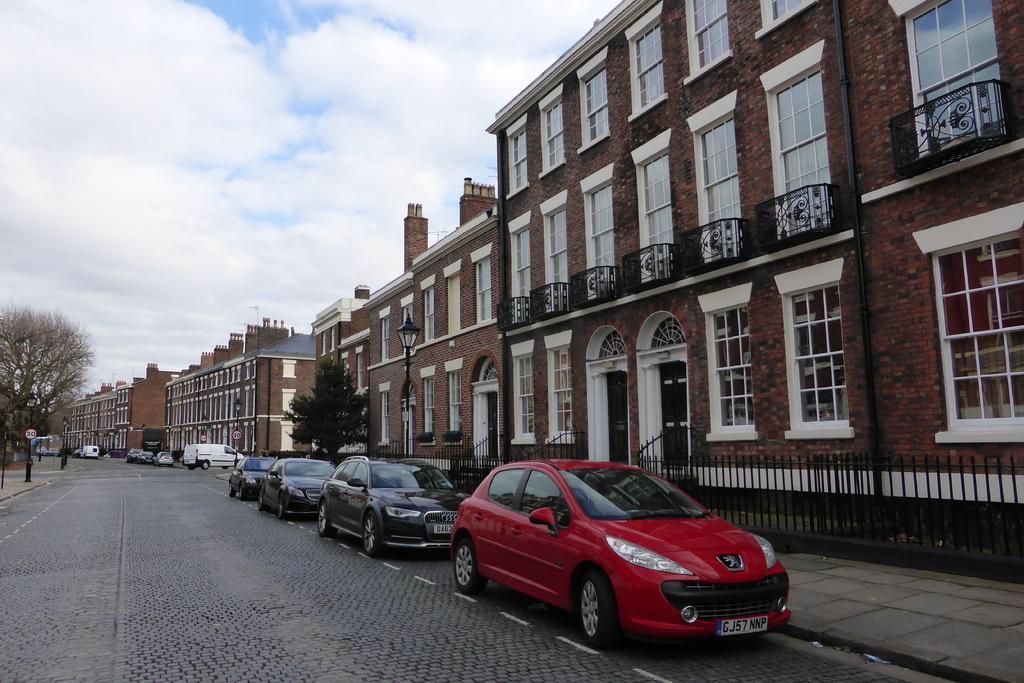Describe this image in one or two sentences. In this image I can see vehicles on the road, at right I can see buildings in brown color, light poles, trees in green color, at top sky is in blue and white color. 